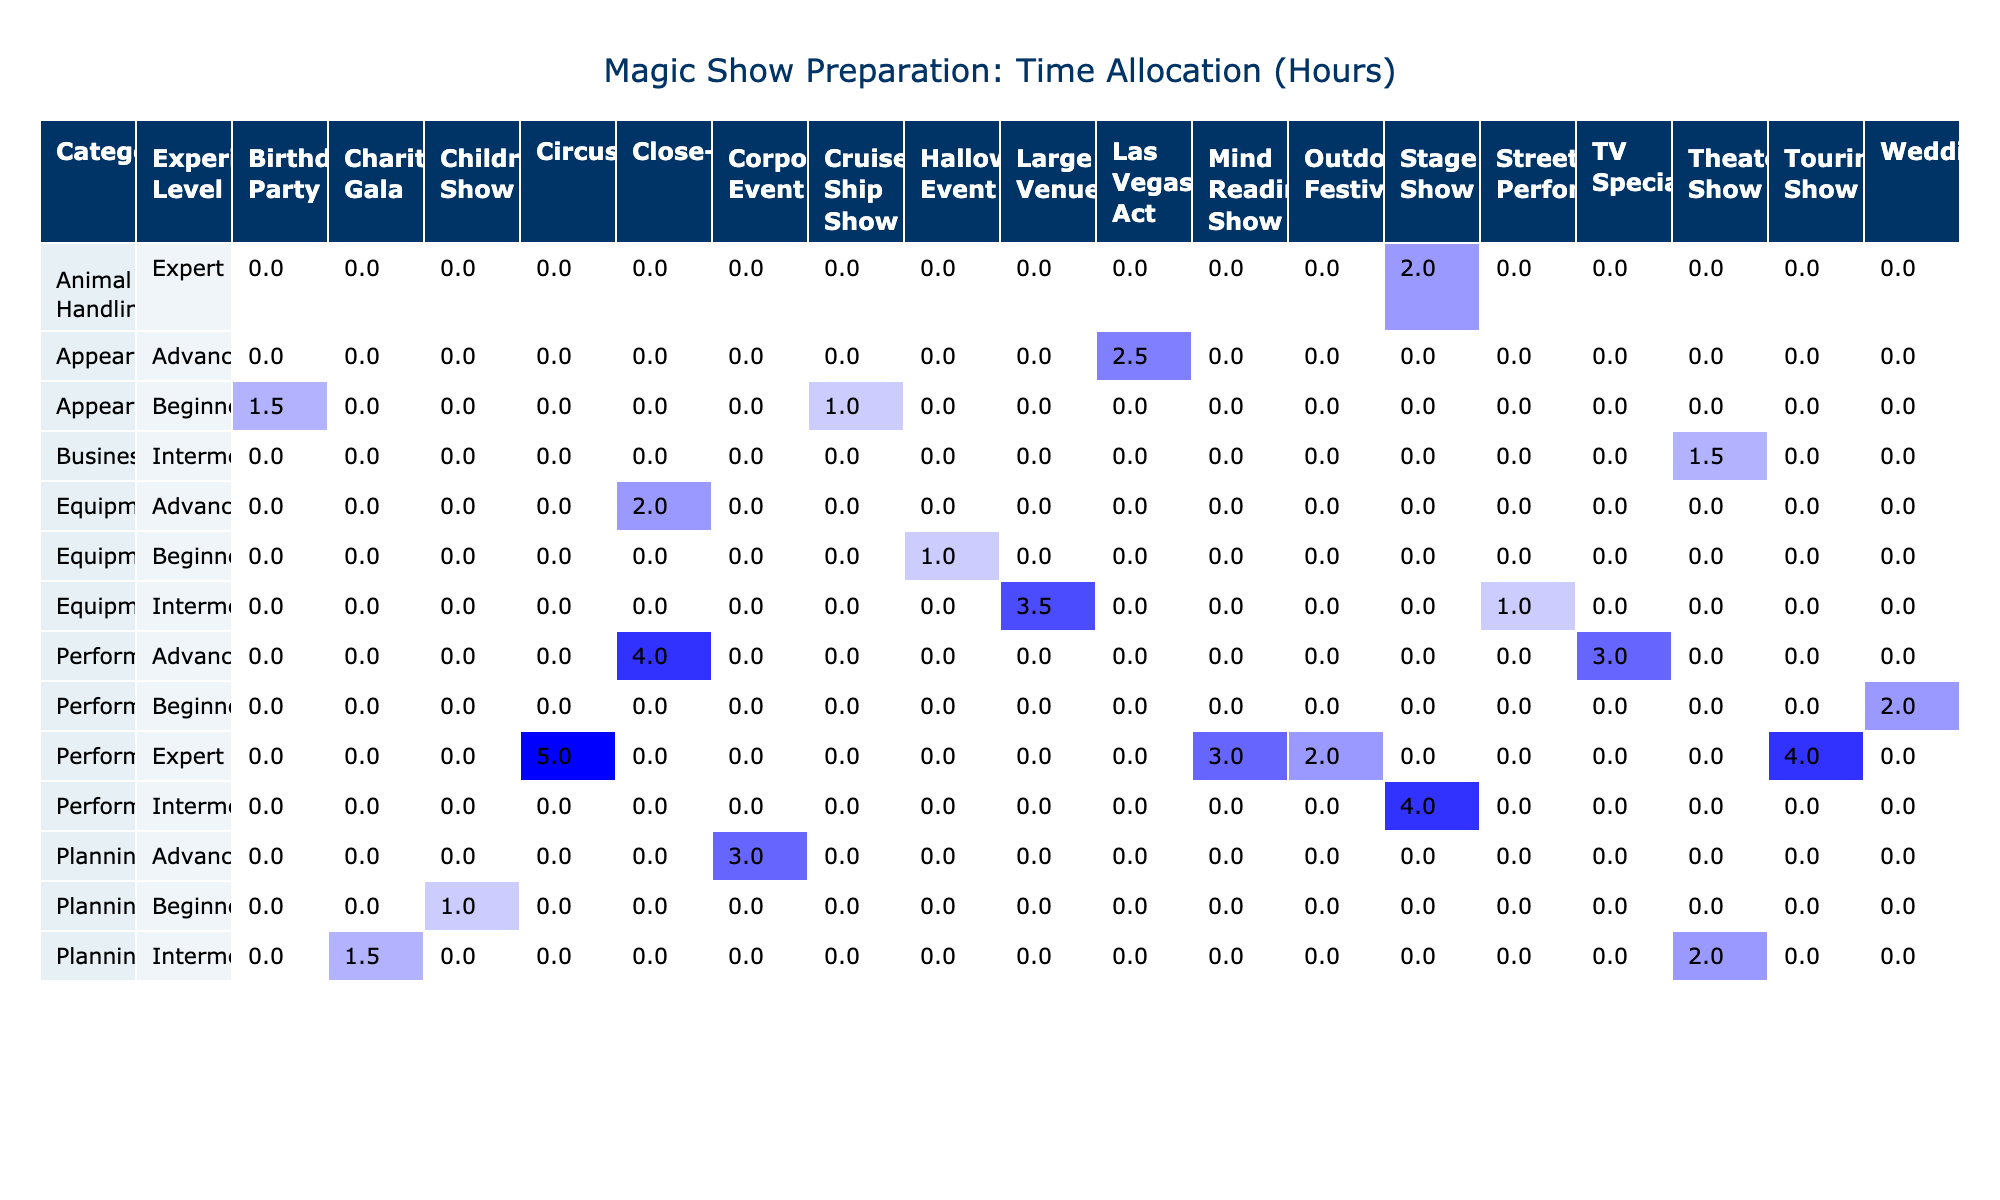What is the total time allocated for performance activities in stage shows? The stage show has two performance activities listed in the table: "Trick Practice" (4 hours) and "Dove Training" (2 hours). Summing these gives us 4 + 2 = 6 hours.
Answer: 6 hours How many hours are dedicated to appearance-related activities across all show types? The appearance-related activities listed are "Costume Design" (1.5 hours), "Set Design" (2.5 hours), and "Costume Fitting" (1 hour). Adding these gives us 1.5 + 2.5 + 1 = 5 hours in total.
Answer: 5 hours Is the average time spent on planning activities greater than 2 hours? There are three planning activities: "Script Writing" (3 hours), "Music Selection" (1 hour), and "Lighting Design" (2 hours). The total is 3 + 1 + 2 = 6 hours with a count of 3 activities. The average is thus 6/3 = 2 hours, which means it is not greater than 2 hours.
Answer: No Which experience level has the most time allocated for preparation activities? The experience levels and their respective total hours are: Intermediate (4 + 1 + 2 + 1.5 + 2 = 10.5 hours), Advanced (3 + 2.5 + 3 + 4 = 12.5 hours), Beginner (1.5 + 1 + 1 + 1 = 4.5 hours), and Expert (5 + 3 + 4 + 2 = 14 hours). Comparing, Expert has the highest allocation with 14 hours.
Answer: Expert What is the total time spent on equipment-related activities in corporate events? The only equipment-related activity listed for corporate events is "Equipment Maintenance," which takes 1 hour. Thus, the total for this specific category is simply 1 hour.
Answer: 1 hour How many more hours are spent on performance activities compared to planning activities? The total hours for performance activities are 4 (Trick Practice) + 5 (Juggling Routine) + 3 (Mentalism Training) + 2 (Fire Eating Practice) + 3 (Levitation Technique) + 4 (Escape Artist Training) = 21 hours. The total hours for planning are 3 (Script Writing) + 1 (Music Selection) + 2 (Lighting Design) = 6 hours. The difference is 21 - 6 = 15 hours.
Answer: 15 hours 